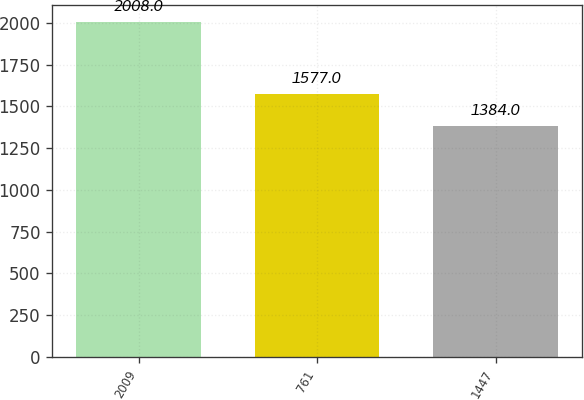Convert chart to OTSL. <chart><loc_0><loc_0><loc_500><loc_500><bar_chart><fcel>2009<fcel>761<fcel>1447<nl><fcel>2008<fcel>1577<fcel>1384<nl></chart> 